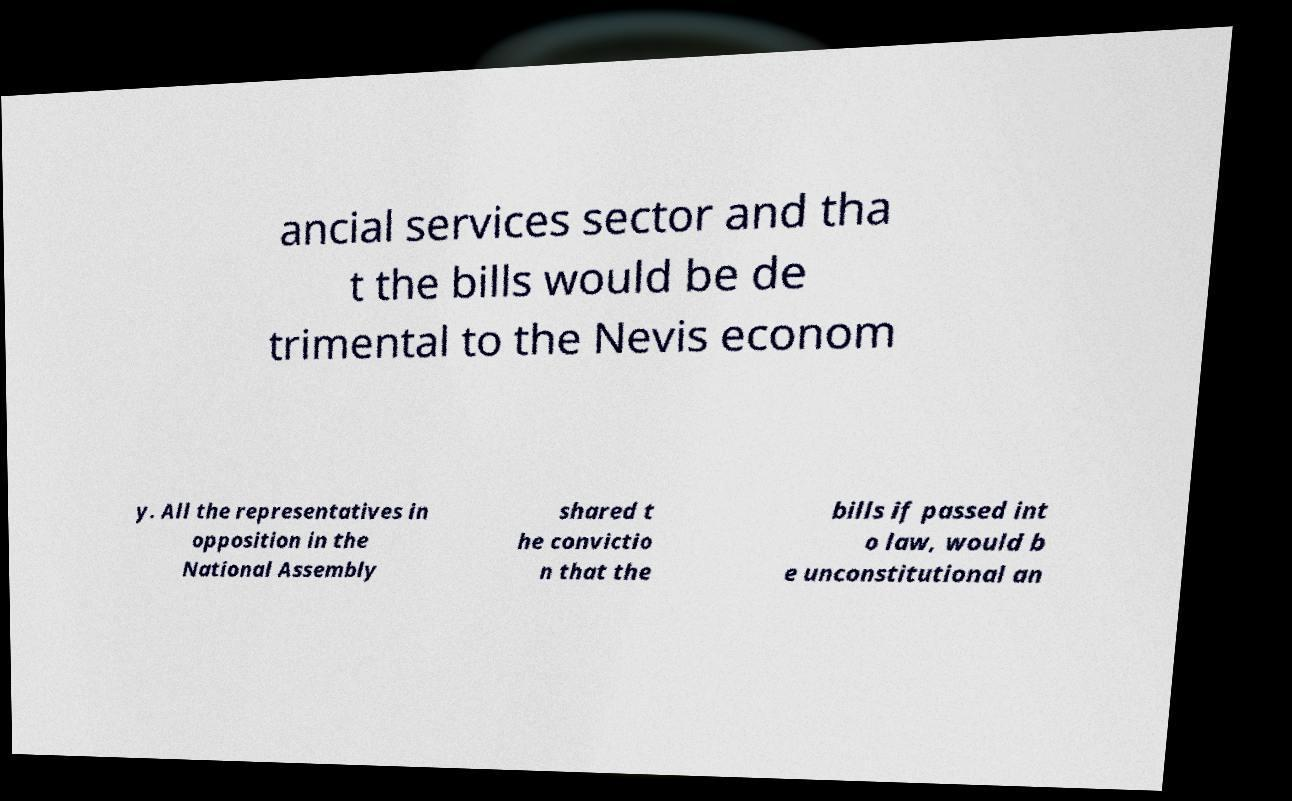I need the written content from this picture converted into text. Can you do that? ancial services sector and tha t the bills would be de trimental to the Nevis econom y. All the representatives in opposition in the National Assembly shared t he convictio n that the bills if passed int o law, would b e unconstitutional an 